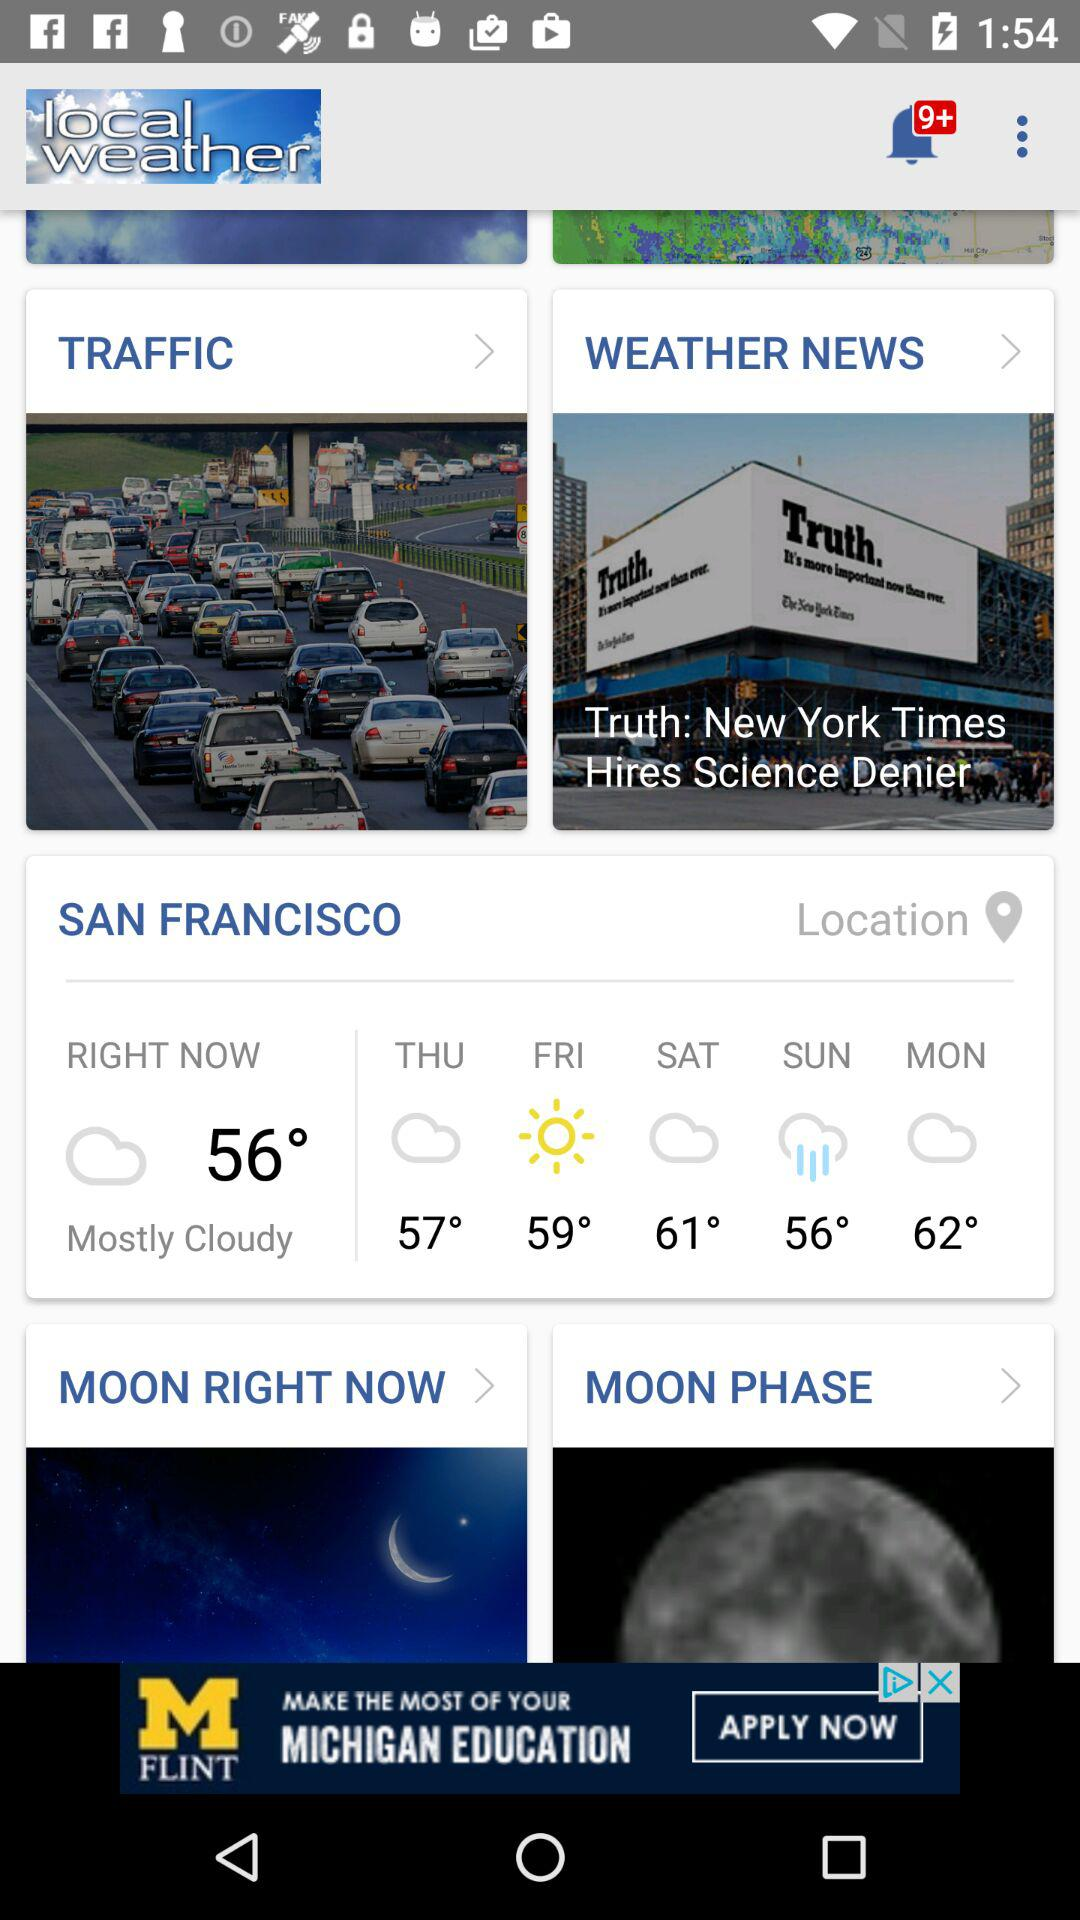How many unread notifications are there? There are more than 9 unread notifications. 